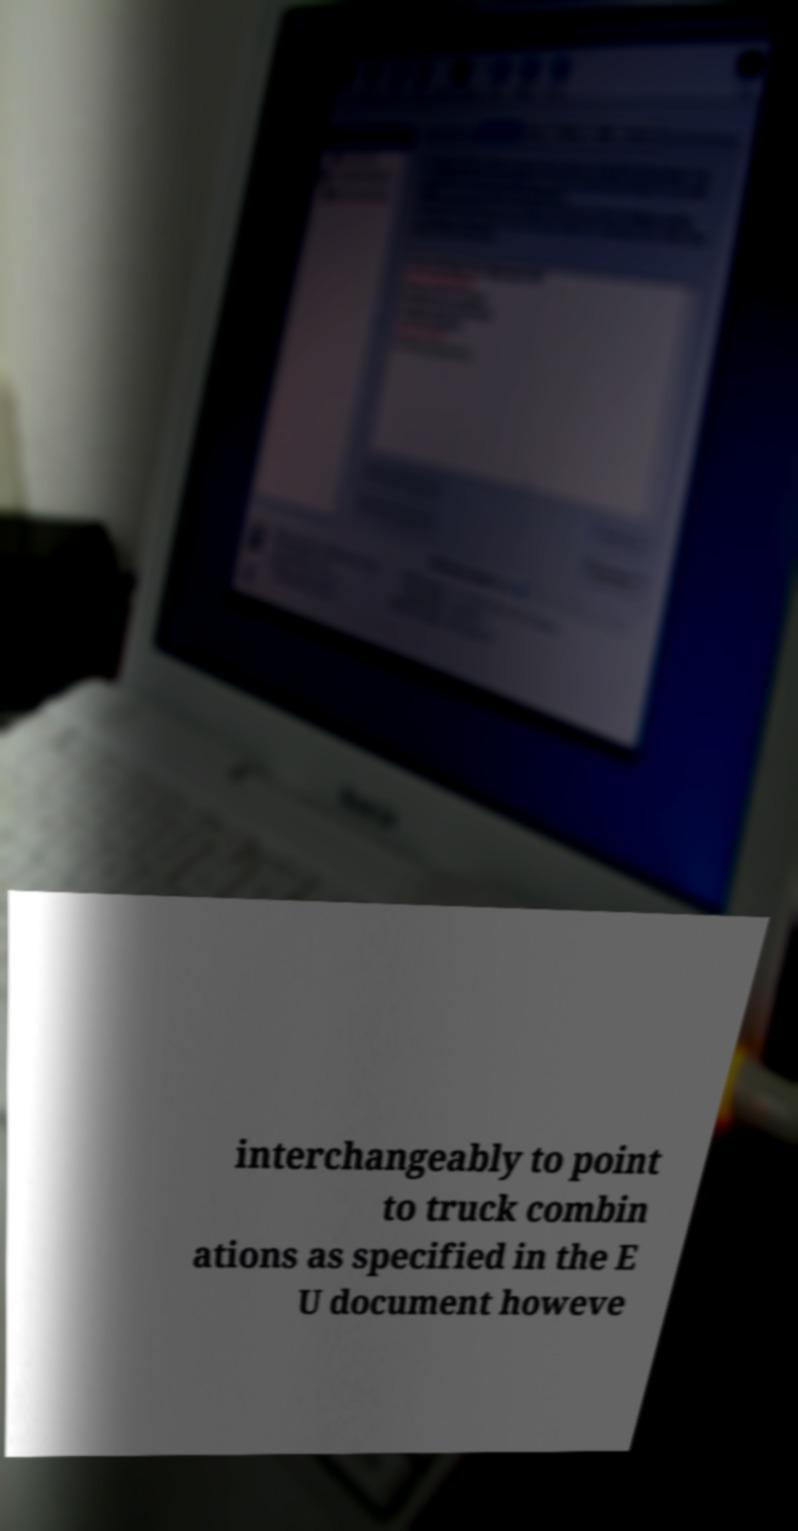For documentation purposes, I need the text within this image transcribed. Could you provide that? interchangeably to point to truck combin ations as specified in the E U document howeve 